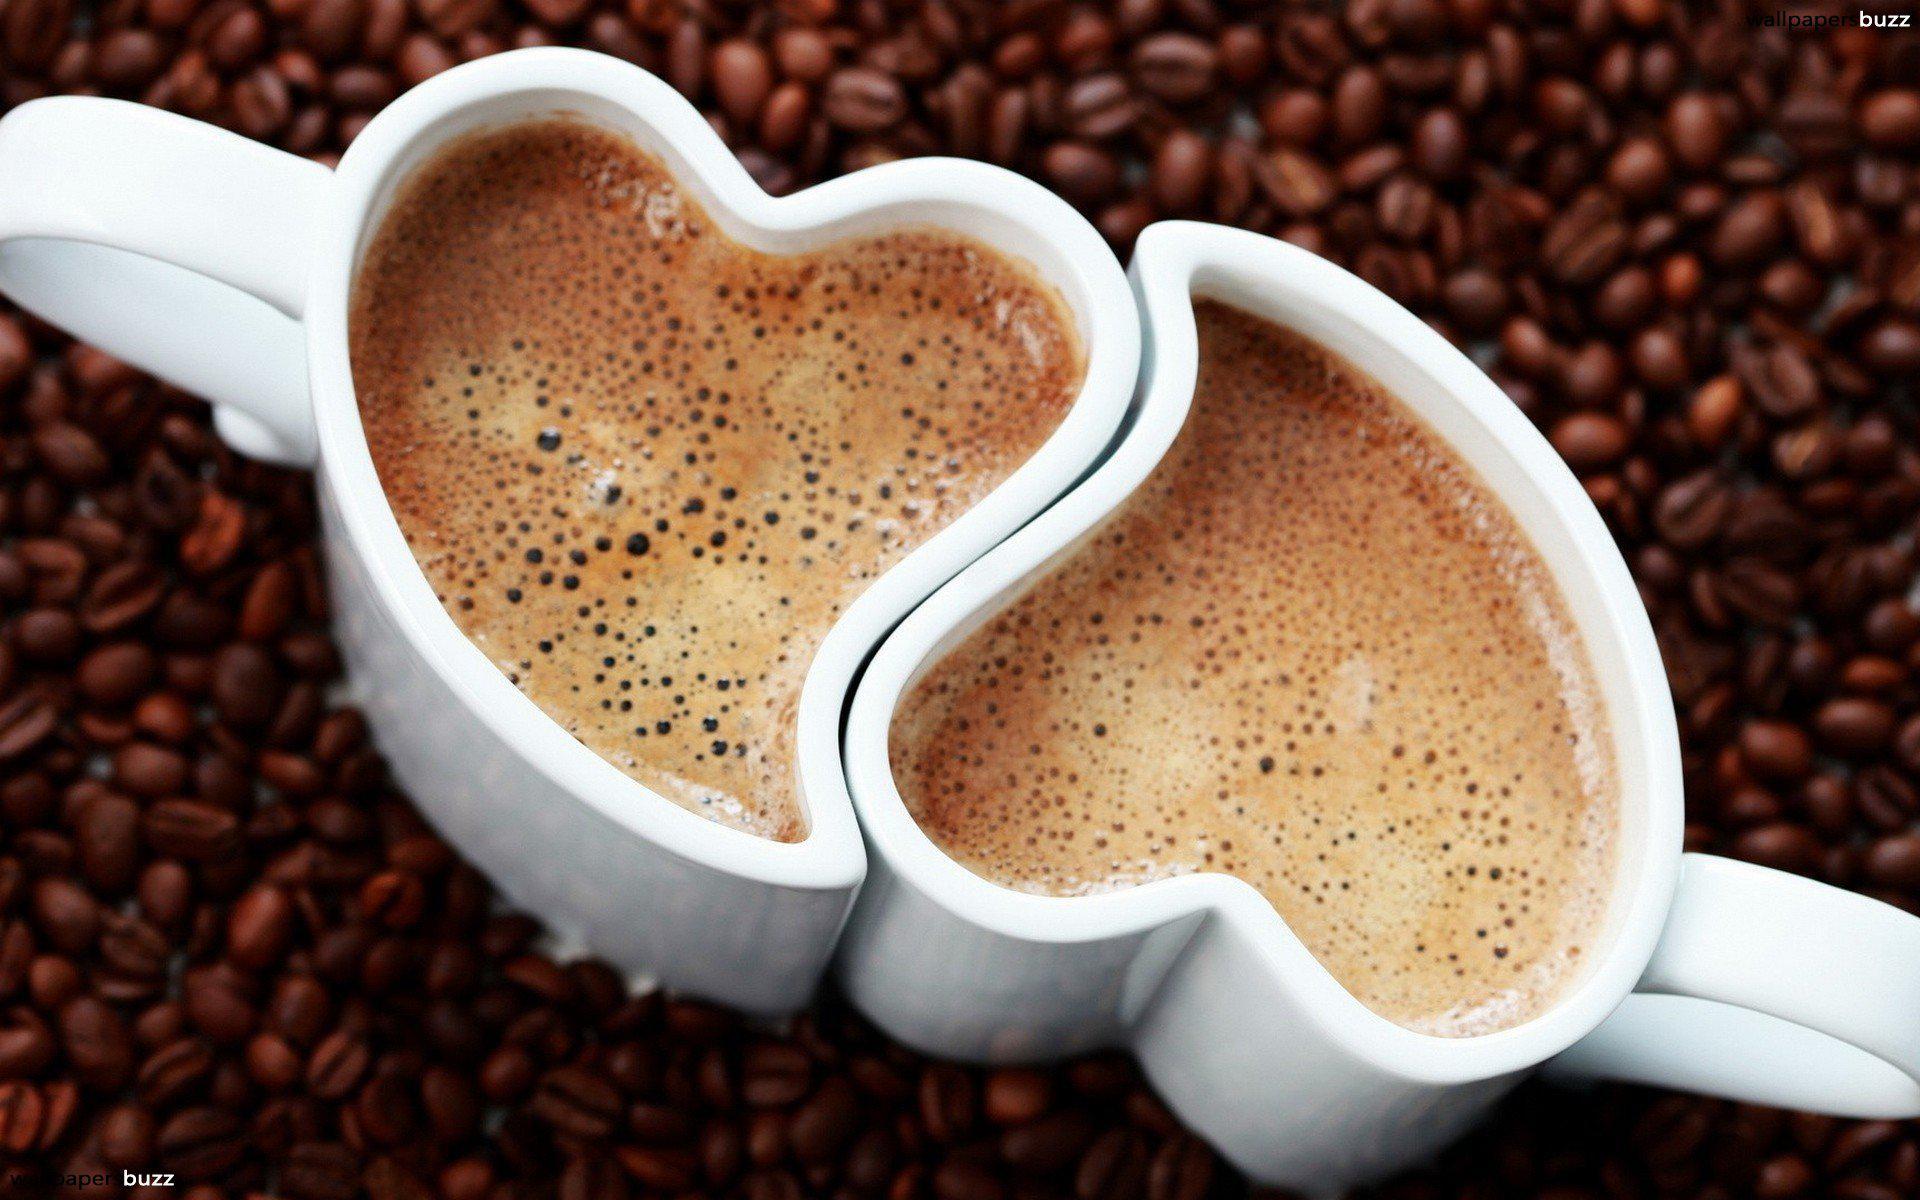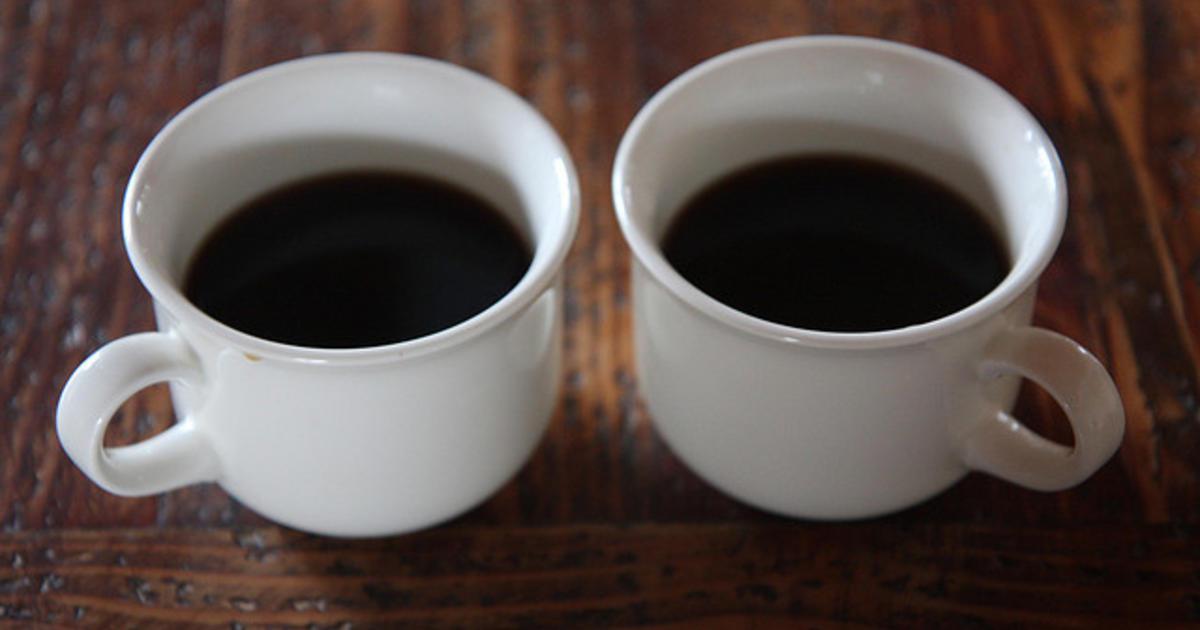The first image is the image on the left, the second image is the image on the right. Evaluate the accuracy of this statement regarding the images: "Each image shows two hot drinks served in matching cups with handles, seen at angle where the contents are visible.". Is it true? Answer yes or no. Yes. The first image is the image on the left, the second image is the image on the right. Given the left and right images, does the statement "An image shows exactly two already filled round white cups sitting side-by-side horizontally without saucers, with handles turned outward." hold true? Answer yes or no. Yes. 